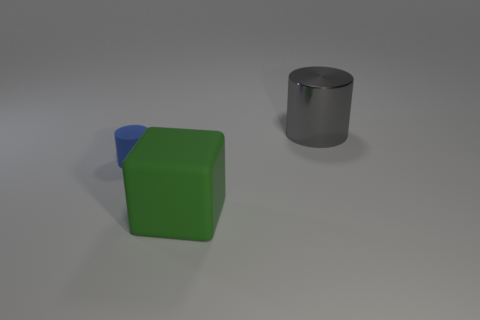Add 2 small green matte cubes. How many objects exist? 5 Subtract all gray cylinders. How many cylinders are left? 1 Subtract 1 cylinders. How many cylinders are left? 1 Subtract all big cylinders. Subtract all cyan rubber things. How many objects are left? 2 Add 1 large green blocks. How many large green blocks are left? 2 Add 3 rubber things. How many rubber things exist? 5 Subtract 0 red blocks. How many objects are left? 3 Subtract all cubes. How many objects are left? 2 Subtract all red cylinders. Subtract all brown balls. How many cylinders are left? 2 Subtract all purple balls. How many gray cylinders are left? 1 